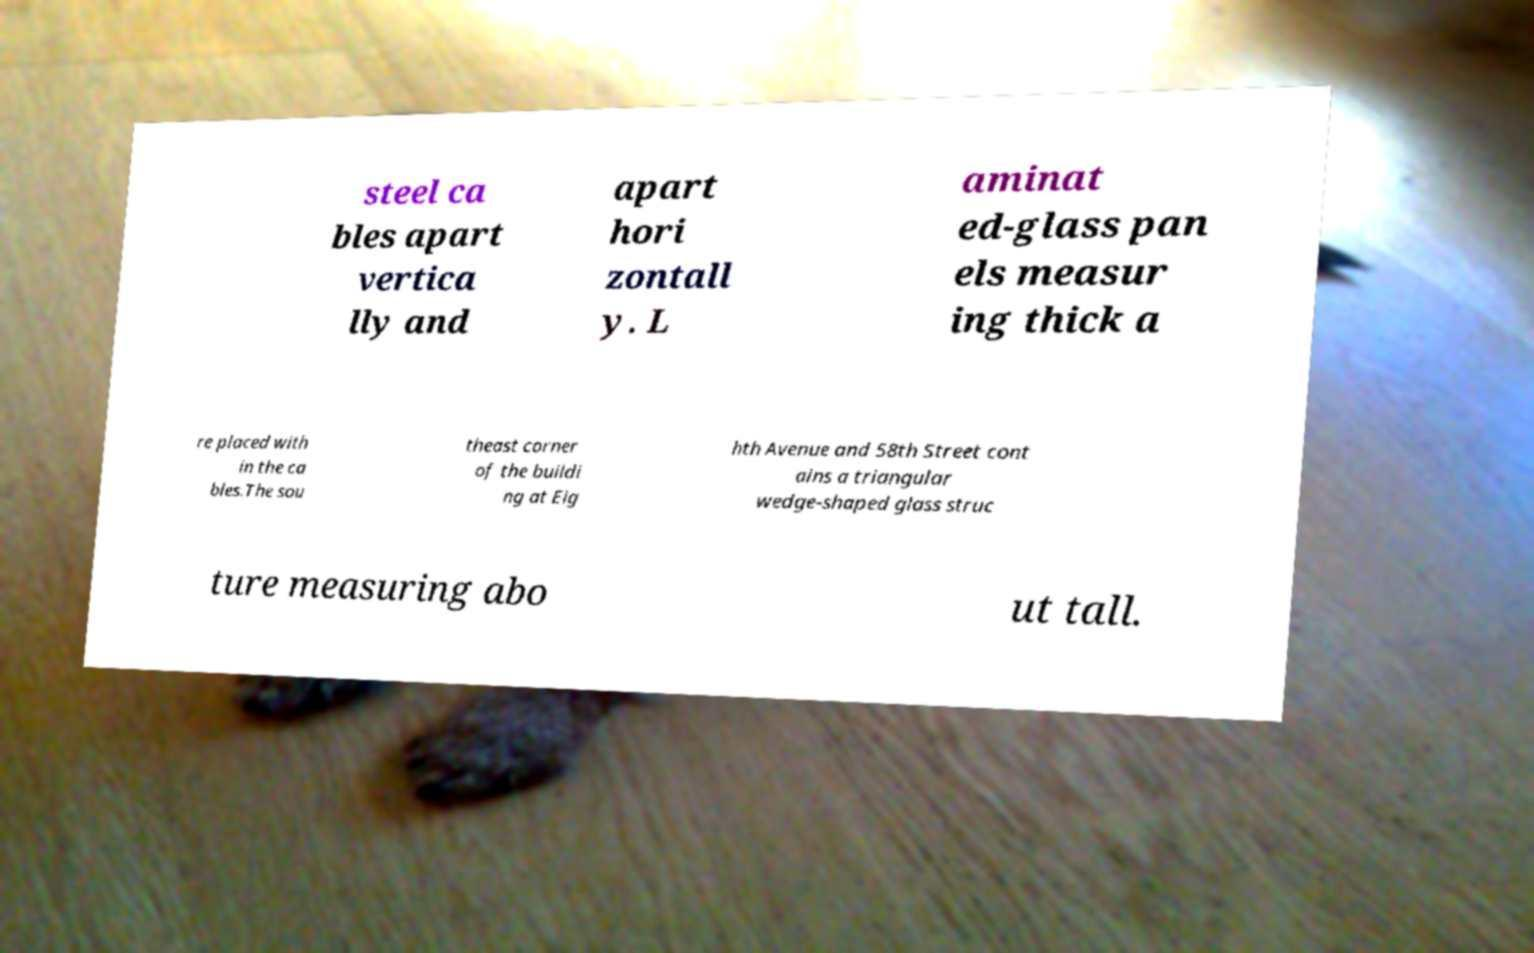Can you read and provide the text displayed in the image?This photo seems to have some interesting text. Can you extract and type it out for me? steel ca bles apart vertica lly and apart hori zontall y. L aminat ed-glass pan els measur ing thick a re placed with in the ca bles.The sou theast corner of the buildi ng at Eig hth Avenue and 58th Street cont ains a triangular wedge-shaped glass struc ture measuring abo ut tall. 